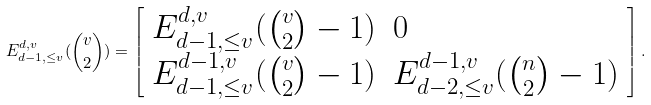<formula> <loc_0><loc_0><loc_500><loc_500>E _ { d - 1 , \leq v } ^ { d , v } ( { v \choose 2 } ) = \left [ \begin{array} { l l } E _ { d - 1 , \leq v } ^ { d , v } ( { v \choose 2 } - 1 ) & 0 \\ E _ { d - 1 , \leq v } ^ { d - 1 , v } ( { v \choose 2 } - 1 ) & E _ { d - 2 , \leq v } ^ { d - 1 , v } ( { n \choose 2 } - 1 ) \end{array} \right ] .</formula> 